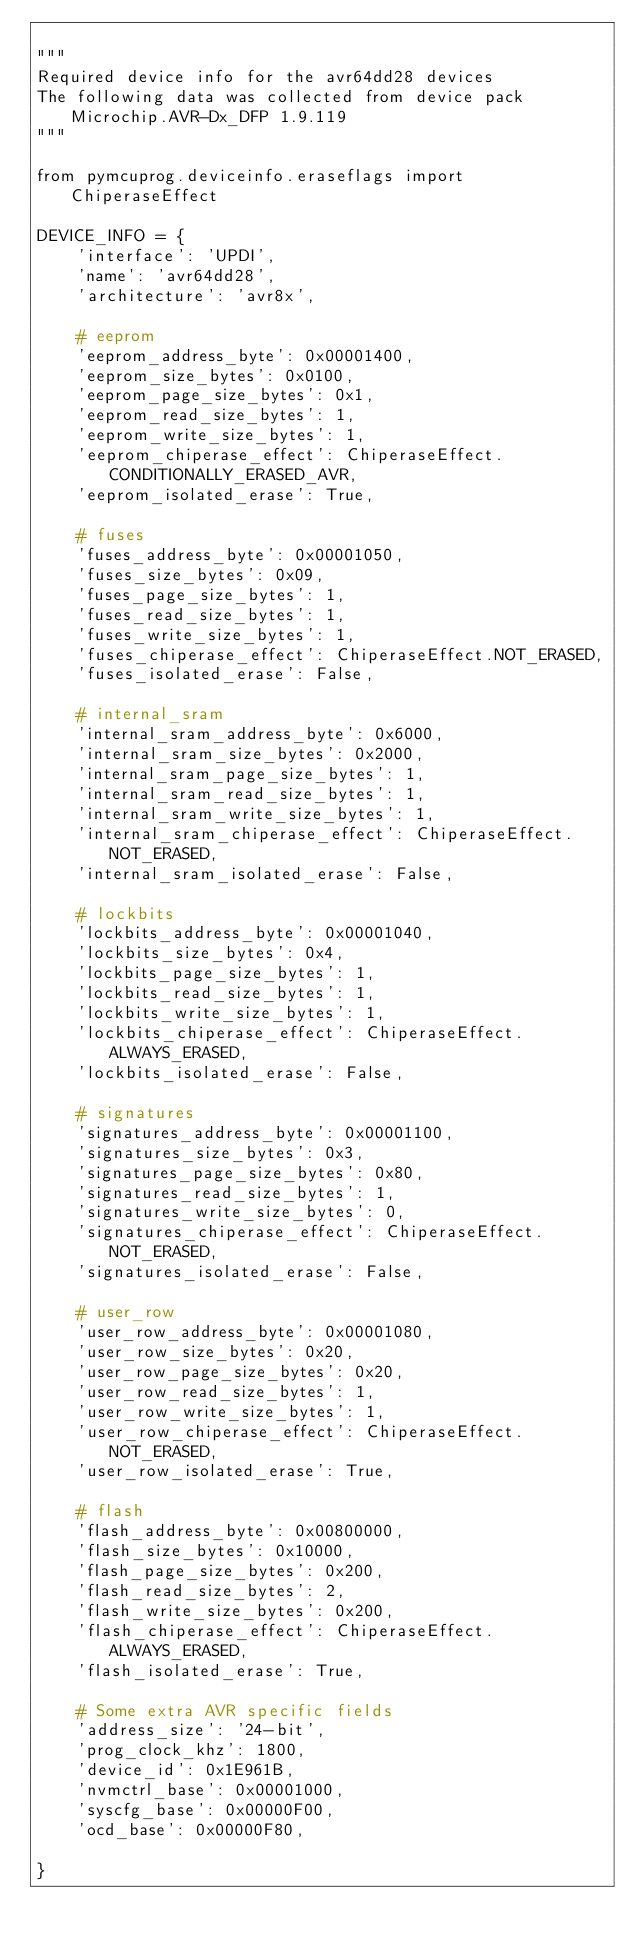Convert code to text. <code><loc_0><loc_0><loc_500><loc_500><_Python_>
"""
Required device info for the avr64dd28 devices
The following data was collected from device pack Microchip.AVR-Dx_DFP 1.9.119
"""

from pymcuprog.deviceinfo.eraseflags import ChiperaseEffect

DEVICE_INFO = {
    'interface': 'UPDI',
    'name': 'avr64dd28',
    'architecture': 'avr8x',

    # eeprom
    'eeprom_address_byte': 0x00001400,
    'eeprom_size_bytes': 0x0100,
    'eeprom_page_size_bytes': 0x1,
    'eeprom_read_size_bytes': 1,
    'eeprom_write_size_bytes': 1,
    'eeprom_chiperase_effect': ChiperaseEffect.CONDITIONALLY_ERASED_AVR,
    'eeprom_isolated_erase': True,

    # fuses
    'fuses_address_byte': 0x00001050,
    'fuses_size_bytes': 0x09,
    'fuses_page_size_bytes': 1,
    'fuses_read_size_bytes': 1,
    'fuses_write_size_bytes': 1,
    'fuses_chiperase_effect': ChiperaseEffect.NOT_ERASED,
    'fuses_isolated_erase': False,

    # internal_sram
    'internal_sram_address_byte': 0x6000,
    'internal_sram_size_bytes': 0x2000,
    'internal_sram_page_size_bytes': 1,
    'internal_sram_read_size_bytes': 1,
    'internal_sram_write_size_bytes': 1,
    'internal_sram_chiperase_effect': ChiperaseEffect.NOT_ERASED,
    'internal_sram_isolated_erase': False,

    # lockbits
    'lockbits_address_byte': 0x00001040,
    'lockbits_size_bytes': 0x4,
    'lockbits_page_size_bytes': 1,
    'lockbits_read_size_bytes': 1,
    'lockbits_write_size_bytes': 1,
    'lockbits_chiperase_effect': ChiperaseEffect.ALWAYS_ERASED,
    'lockbits_isolated_erase': False,

    # signatures
    'signatures_address_byte': 0x00001100,
    'signatures_size_bytes': 0x3,
    'signatures_page_size_bytes': 0x80,
    'signatures_read_size_bytes': 1,
    'signatures_write_size_bytes': 0,
    'signatures_chiperase_effect': ChiperaseEffect.NOT_ERASED,
    'signatures_isolated_erase': False,

    # user_row
    'user_row_address_byte': 0x00001080,
    'user_row_size_bytes': 0x20,
    'user_row_page_size_bytes': 0x20,
    'user_row_read_size_bytes': 1,
    'user_row_write_size_bytes': 1,
    'user_row_chiperase_effect': ChiperaseEffect.NOT_ERASED,
    'user_row_isolated_erase': True,

    # flash
    'flash_address_byte': 0x00800000,
    'flash_size_bytes': 0x10000,
    'flash_page_size_bytes': 0x200,
    'flash_read_size_bytes': 2,
    'flash_write_size_bytes': 0x200,
    'flash_chiperase_effect': ChiperaseEffect.ALWAYS_ERASED,
    'flash_isolated_erase': True,

    # Some extra AVR specific fields
    'address_size': '24-bit',
    'prog_clock_khz': 1800,
    'device_id': 0x1E961B,
    'nvmctrl_base': 0x00001000,
    'syscfg_base': 0x00000F00,
    'ocd_base': 0x00000F80,

}
</code> 